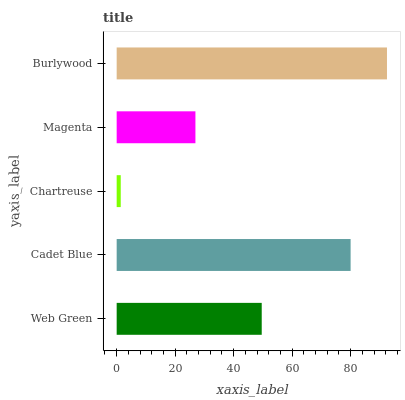Is Chartreuse the minimum?
Answer yes or no. Yes. Is Burlywood the maximum?
Answer yes or no. Yes. Is Cadet Blue the minimum?
Answer yes or no. No. Is Cadet Blue the maximum?
Answer yes or no. No. Is Cadet Blue greater than Web Green?
Answer yes or no. Yes. Is Web Green less than Cadet Blue?
Answer yes or no. Yes. Is Web Green greater than Cadet Blue?
Answer yes or no. No. Is Cadet Blue less than Web Green?
Answer yes or no. No. Is Web Green the high median?
Answer yes or no. Yes. Is Web Green the low median?
Answer yes or no. Yes. Is Magenta the high median?
Answer yes or no. No. Is Cadet Blue the low median?
Answer yes or no. No. 